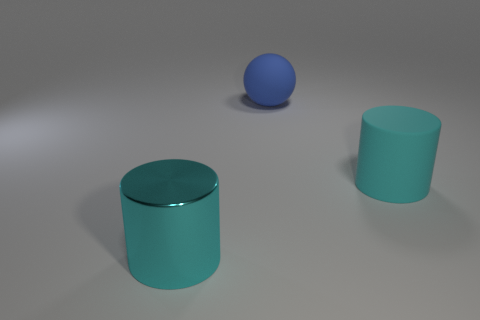Subtract 2 cylinders. How many cylinders are left? 0 Add 3 tiny gray matte cylinders. How many objects exist? 6 Subtract all purple cylinders. Subtract all blue cubes. How many cylinders are left? 2 Subtract all blue blocks. How many purple cylinders are left? 0 Subtract all large spheres. Subtract all cyan matte cylinders. How many objects are left? 1 Add 2 large rubber balls. How many large rubber balls are left? 3 Add 1 cyan metal cylinders. How many cyan metal cylinders exist? 2 Subtract 0 gray cylinders. How many objects are left? 3 Subtract all spheres. How many objects are left? 2 